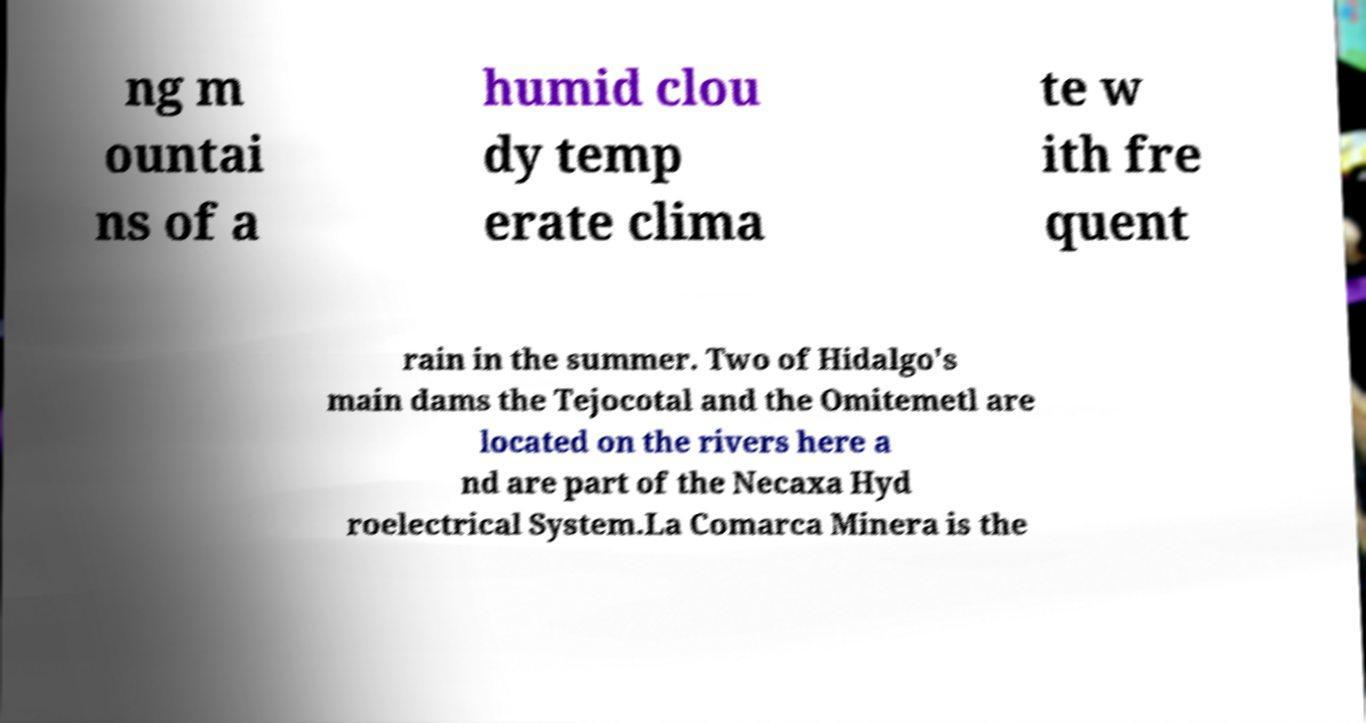Please read and relay the text visible in this image. What does it say? ng m ountai ns of a humid clou dy temp erate clima te w ith fre quent rain in the summer. Two of Hidalgo's main dams the Tejocotal and the Omitemetl are located on the rivers here a nd are part of the Necaxa Hyd roelectrical System.La Comarca Minera is the 